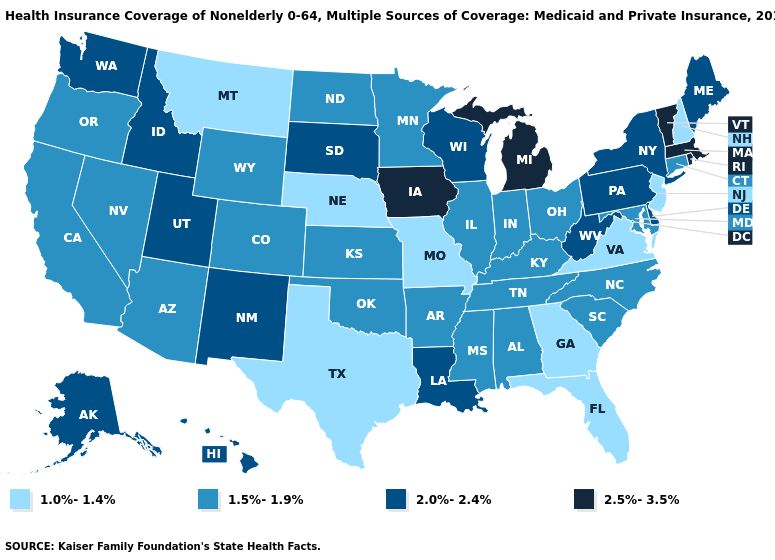Which states have the lowest value in the MidWest?
Answer briefly. Missouri, Nebraska. Name the states that have a value in the range 1.5%-1.9%?
Short answer required. Alabama, Arizona, Arkansas, California, Colorado, Connecticut, Illinois, Indiana, Kansas, Kentucky, Maryland, Minnesota, Mississippi, Nevada, North Carolina, North Dakota, Ohio, Oklahoma, Oregon, South Carolina, Tennessee, Wyoming. Which states have the lowest value in the USA?
Be succinct. Florida, Georgia, Missouri, Montana, Nebraska, New Hampshire, New Jersey, Texas, Virginia. What is the highest value in states that border Louisiana?
Write a very short answer. 1.5%-1.9%. Which states have the lowest value in the MidWest?
Be succinct. Missouri, Nebraska. What is the highest value in states that border Illinois?
Concise answer only. 2.5%-3.5%. What is the value of Idaho?
Write a very short answer. 2.0%-2.4%. Does the first symbol in the legend represent the smallest category?
Give a very brief answer. Yes. What is the value of Oregon?
Quick response, please. 1.5%-1.9%. Among the states that border Kansas , does Missouri have the lowest value?
Be succinct. Yes. Among the states that border Ohio , does Michigan have the highest value?
Quick response, please. Yes. What is the value of Utah?
Answer briefly. 2.0%-2.4%. What is the value of Rhode Island?
Write a very short answer. 2.5%-3.5%. Does Wyoming have the same value as Idaho?
Concise answer only. No. What is the value of Maine?
Concise answer only. 2.0%-2.4%. 